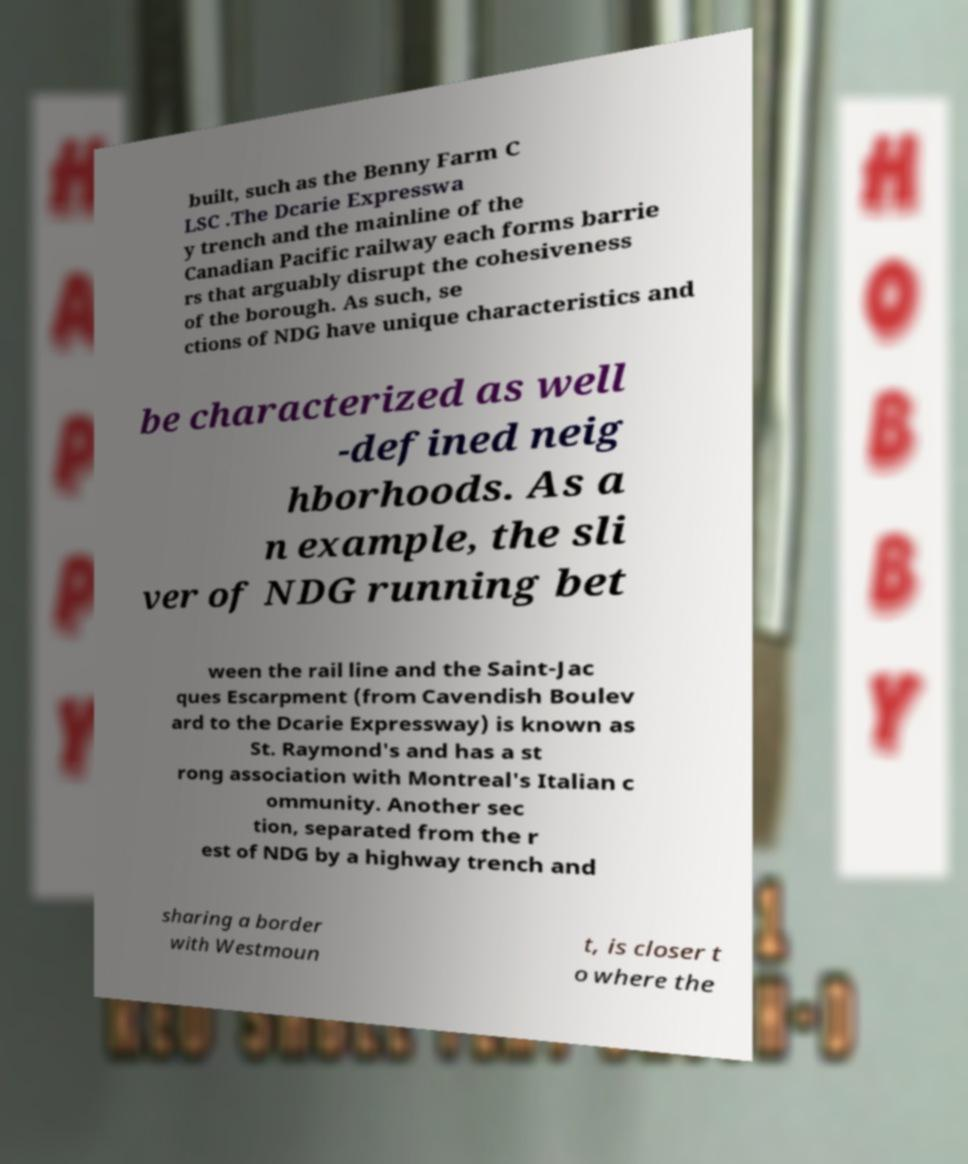Please read and relay the text visible in this image. What does it say? built, such as the Benny Farm C LSC .The Dcarie Expresswa y trench and the mainline of the Canadian Pacific railway each forms barrie rs that arguably disrupt the cohesiveness of the borough. As such, se ctions of NDG have unique characteristics and be characterized as well -defined neig hborhoods. As a n example, the sli ver of NDG running bet ween the rail line and the Saint-Jac ques Escarpment (from Cavendish Boulev ard to the Dcarie Expressway) is known as St. Raymond's and has a st rong association with Montreal's Italian c ommunity. Another sec tion, separated from the r est of NDG by a highway trench and sharing a border with Westmoun t, is closer t o where the 